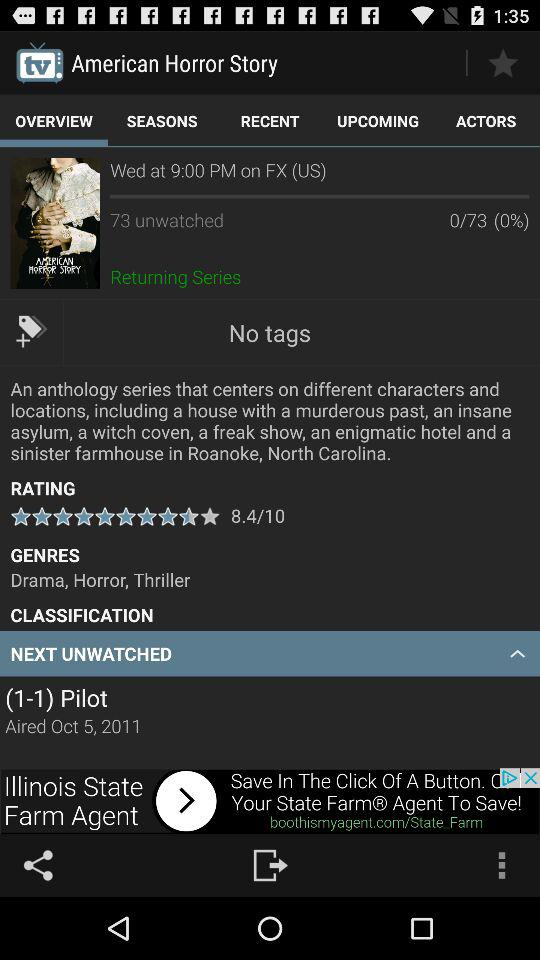What type of movie is "American Horror Story"? "American Horror Story" is a drama, horror and thriller movie. 